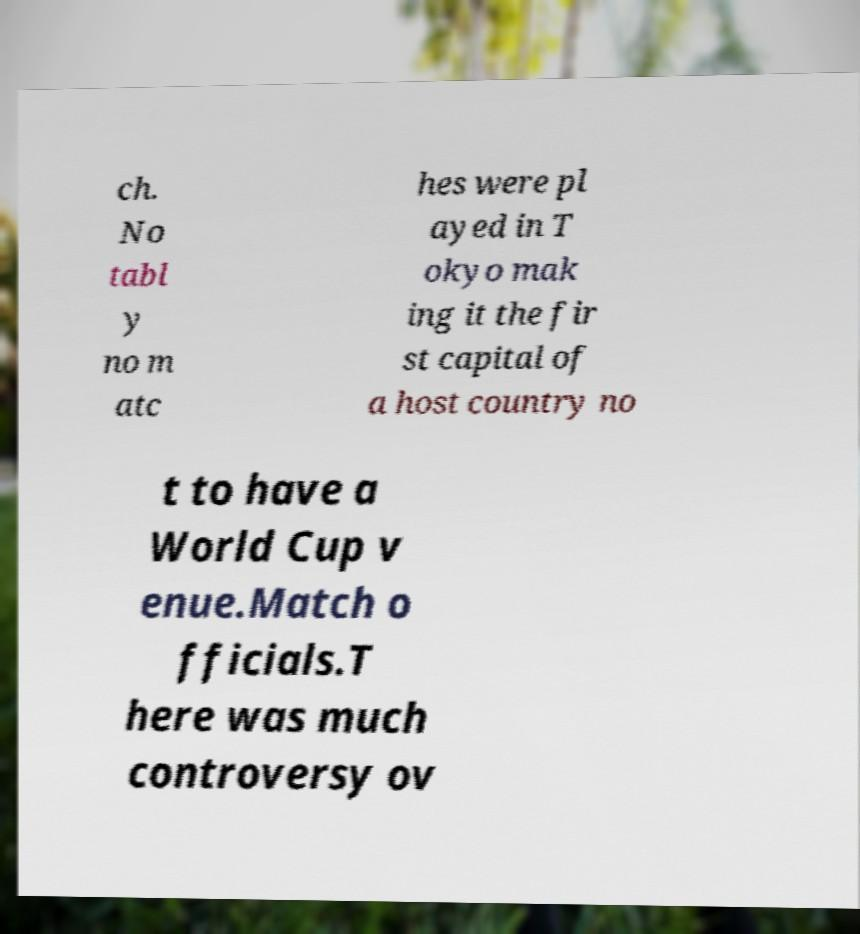I need the written content from this picture converted into text. Can you do that? ch. No tabl y no m atc hes were pl ayed in T okyo mak ing it the fir st capital of a host country no t to have a World Cup v enue.Match o fficials.T here was much controversy ov 